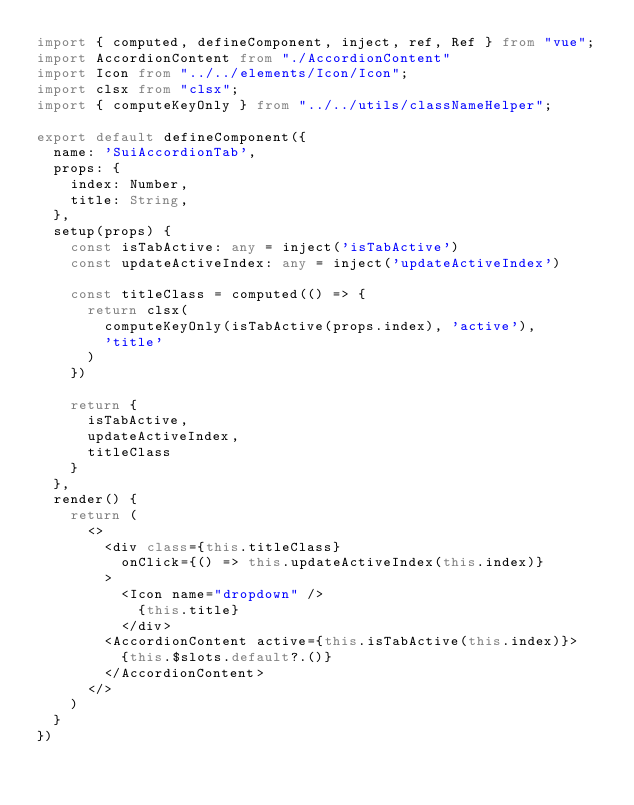Convert code to text. <code><loc_0><loc_0><loc_500><loc_500><_TypeScript_>import { computed, defineComponent, inject, ref, Ref } from "vue";
import AccordionContent from "./AccordionContent"
import Icon from "../../elements/Icon/Icon";
import clsx from "clsx";
import { computeKeyOnly } from "../../utils/classNameHelper";

export default defineComponent({
  name: 'SuiAccordionTab',
  props: {
    index: Number,
    title: String,
  },
  setup(props) {
    const isTabActive: any = inject('isTabActive')
    const updateActiveIndex: any = inject('updateActiveIndex')

    const titleClass = computed(() => {
      return clsx(
        computeKeyOnly(isTabActive(props.index), 'active'),
        'title'
      )
    })

    return {
      isTabActive,
      updateActiveIndex,
      titleClass
    }
  },
  render() {
    return (
      <>
        <div class={this.titleClass}
          onClick={() => this.updateActiveIndex(this.index)}
        >
          <Icon name="dropdown" />
            {this.title}
          </div>
        <AccordionContent active={this.isTabActive(this.index)}>
          {this.$slots.default?.()}
        </AccordionContent>
      </>
    )
  }
})</code> 